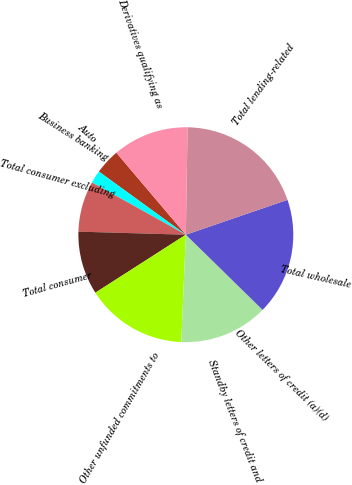<chart> <loc_0><loc_0><loc_500><loc_500><pie_chart><fcel>Auto<fcel>Business banking<fcel>Total consumer excluding<fcel>Total consumer<fcel>Other unfunded commitments to<fcel>Standby letters of credit and<fcel>Other letters of credit (a)(d)<fcel>Total wholesale<fcel>Total lending-related<fcel>Derivatives qualifying as<nl><fcel>3.82%<fcel>1.91%<fcel>7.63%<fcel>9.53%<fcel>15.25%<fcel>13.34%<fcel>0.01%<fcel>17.59%<fcel>19.49%<fcel>11.44%<nl></chart> 